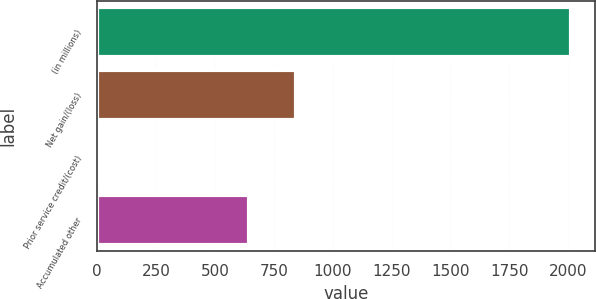Convert chart to OTSL. <chart><loc_0><loc_0><loc_500><loc_500><bar_chart><fcel>(in millions)<fcel>Net gain/(loss)<fcel>Prior service credit/(cost)<fcel>Accumulated other<nl><fcel>2013<fcel>843.9<fcel>14<fcel>644<nl></chart> 